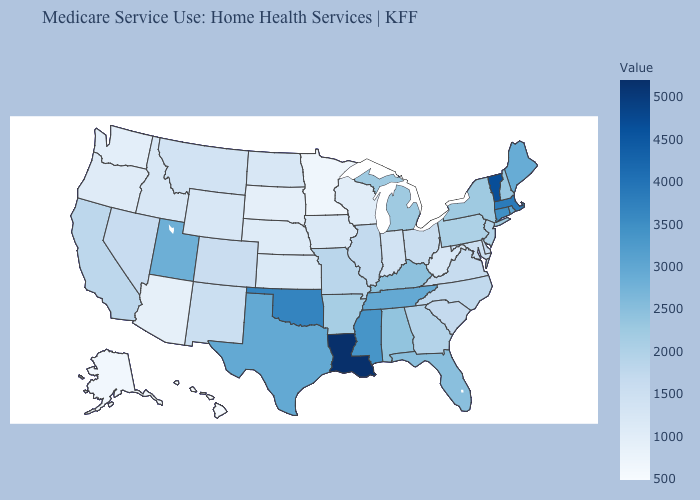Among the states that border Ohio , does West Virginia have the lowest value?
Keep it brief. Yes. Does Wyoming have the lowest value in the USA?
Keep it brief. No. Which states hav the highest value in the MidWest?
Short answer required. Michigan. 